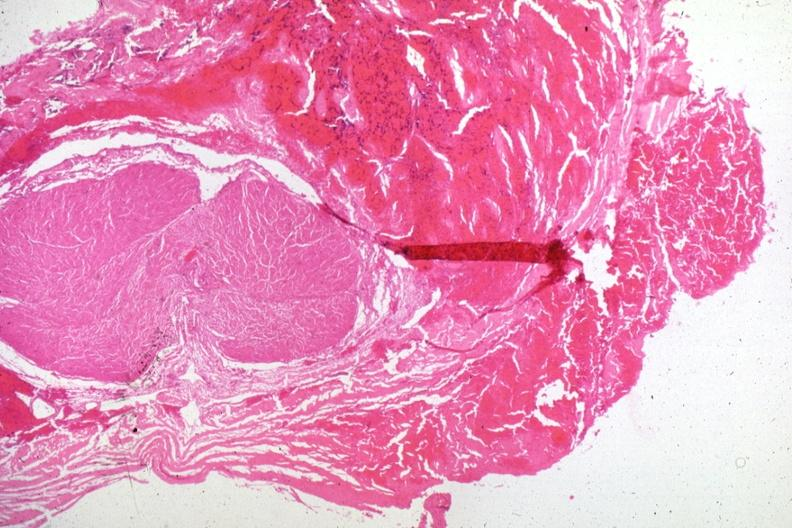does this image show hemorrhagic tissue in region of lesion several slides on this case?
Answer the question using a single word or phrase. Yes 